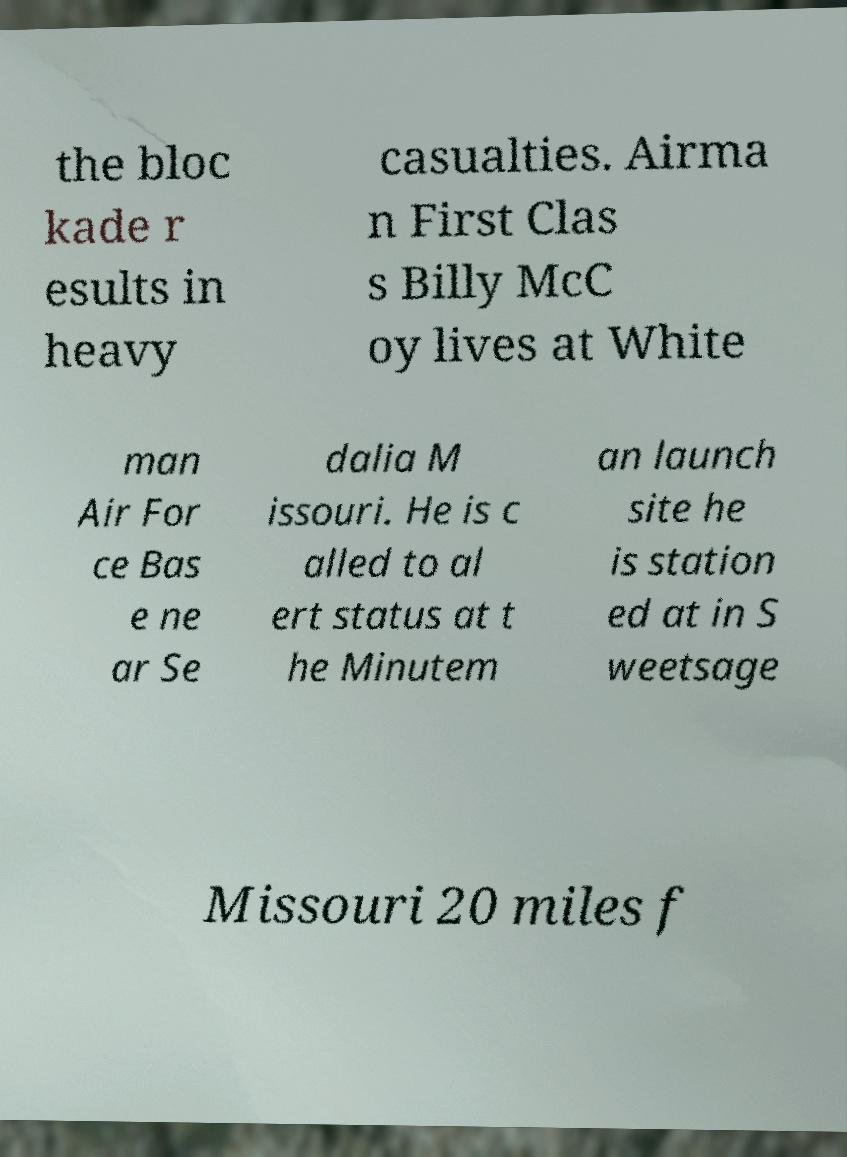Can you accurately transcribe the text from the provided image for me? the bloc kade r esults in heavy casualties. Airma n First Clas s Billy McC oy lives at White man Air For ce Bas e ne ar Se dalia M issouri. He is c alled to al ert status at t he Minutem an launch site he is station ed at in S weetsage Missouri 20 miles f 